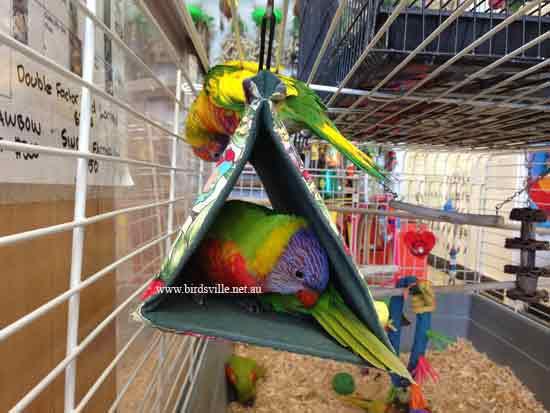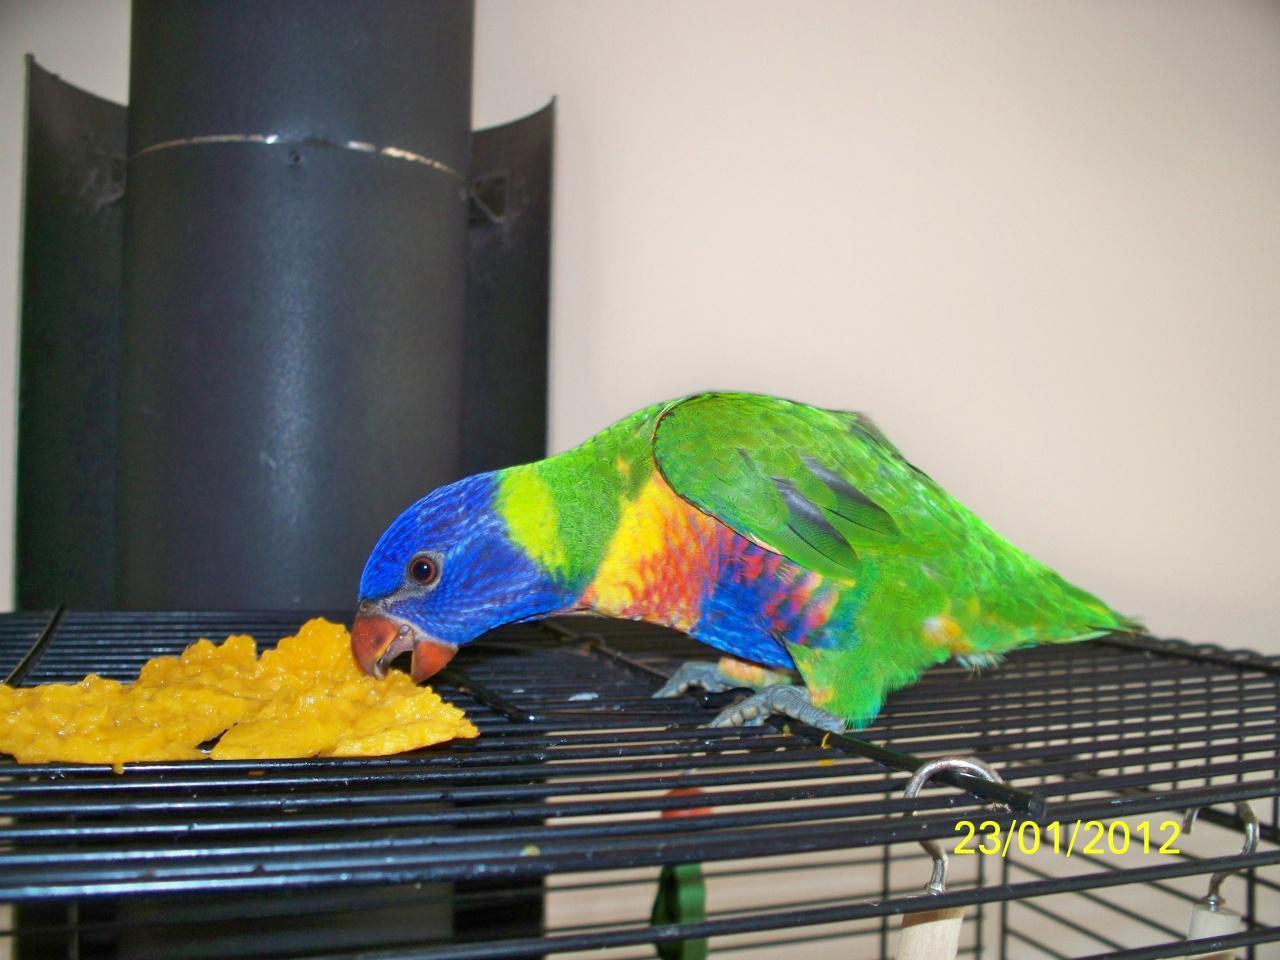The first image is the image on the left, the second image is the image on the right. Analyze the images presented: Is the assertion "Only one parrot can be seen in each of the images." valid? Answer yes or no. No. The first image is the image on the left, the second image is the image on the right. Given the left and right images, does the statement "There is a bird that is hanging with its feet above most of its body." hold true? Answer yes or no. No. 